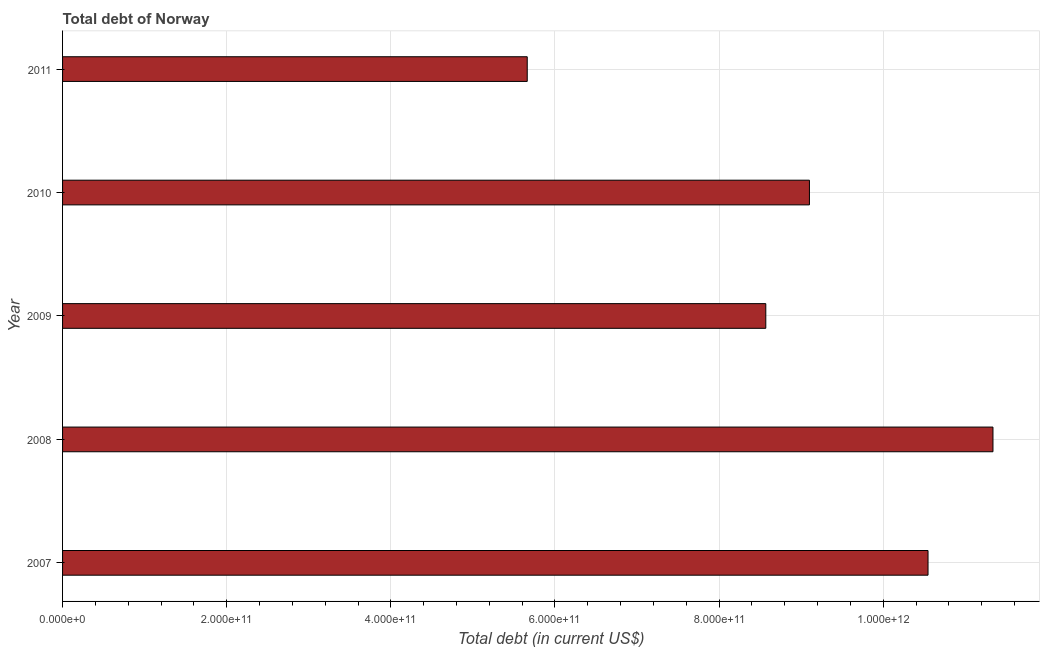Does the graph contain grids?
Your response must be concise. Yes. What is the title of the graph?
Keep it short and to the point. Total debt of Norway. What is the label or title of the X-axis?
Ensure brevity in your answer.  Total debt (in current US$). What is the total debt in 2008?
Ensure brevity in your answer.  1.13e+12. Across all years, what is the maximum total debt?
Your answer should be very brief. 1.13e+12. Across all years, what is the minimum total debt?
Offer a terse response. 5.66e+11. What is the sum of the total debt?
Your answer should be very brief. 4.52e+12. What is the difference between the total debt in 2007 and 2010?
Offer a very short reply. 1.45e+11. What is the average total debt per year?
Give a very brief answer. 9.04e+11. What is the median total debt?
Keep it short and to the point. 9.10e+11. In how many years, is the total debt greater than 1120000000000 US$?
Offer a terse response. 1. Do a majority of the years between 2009 and 2011 (inclusive) have total debt greater than 960000000000 US$?
Your response must be concise. No. What is the ratio of the total debt in 2008 to that in 2009?
Your answer should be very brief. 1.32. What is the difference between the highest and the second highest total debt?
Provide a short and direct response. 7.91e+1. What is the difference between the highest and the lowest total debt?
Keep it short and to the point. 5.68e+11. In how many years, is the total debt greater than the average total debt taken over all years?
Offer a very short reply. 3. How many bars are there?
Provide a succinct answer. 5. What is the difference between two consecutive major ticks on the X-axis?
Offer a terse response. 2.00e+11. What is the Total debt (in current US$) in 2007?
Offer a terse response. 1.05e+12. What is the Total debt (in current US$) in 2008?
Keep it short and to the point. 1.13e+12. What is the Total debt (in current US$) in 2009?
Give a very brief answer. 8.57e+11. What is the Total debt (in current US$) in 2010?
Ensure brevity in your answer.  9.10e+11. What is the Total debt (in current US$) in 2011?
Offer a terse response. 5.66e+11. What is the difference between the Total debt (in current US$) in 2007 and 2008?
Keep it short and to the point. -7.91e+1. What is the difference between the Total debt (in current US$) in 2007 and 2009?
Your answer should be compact. 1.98e+11. What is the difference between the Total debt (in current US$) in 2007 and 2010?
Make the answer very short. 1.45e+11. What is the difference between the Total debt (in current US$) in 2007 and 2011?
Provide a succinct answer. 4.88e+11. What is the difference between the Total debt (in current US$) in 2008 and 2009?
Your answer should be very brief. 2.77e+11. What is the difference between the Total debt (in current US$) in 2008 and 2010?
Give a very brief answer. 2.24e+11. What is the difference between the Total debt (in current US$) in 2008 and 2011?
Make the answer very short. 5.68e+11. What is the difference between the Total debt (in current US$) in 2009 and 2010?
Ensure brevity in your answer.  -5.32e+1. What is the difference between the Total debt (in current US$) in 2009 and 2011?
Offer a terse response. 2.91e+11. What is the difference between the Total debt (in current US$) in 2010 and 2011?
Offer a terse response. 3.44e+11. What is the ratio of the Total debt (in current US$) in 2007 to that in 2008?
Your answer should be very brief. 0.93. What is the ratio of the Total debt (in current US$) in 2007 to that in 2009?
Your answer should be compact. 1.23. What is the ratio of the Total debt (in current US$) in 2007 to that in 2010?
Your answer should be very brief. 1.16. What is the ratio of the Total debt (in current US$) in 2007 to that in 2011?
Your answer should be compact. 1.86. What is the ratio of the Total debt (in current US$) in 2008 to that in 2009?
Make the answer very short. 1.32. What is the ratio of the Total debt (in current US$) in 2008 to that in 2010?
Provide a succinct answer. 1.25. What is the ratio of the Total debt (in current US$) in 2008 to that in 2011?
Ensure brevity in your answer.  2. What is the ratio of the Total debt (in current US$) in 2009 to that in 2010?
Ensure brevity in your answer.  0.94. What is the ratio of the Total debt (in current US$) in 2009 to that in 2011?
Offer a terse response. 1.51. What is the ratio of the Total debt (in current US$) in 2010 to that in 2011?
Keep it short and to the point. 1.61. 